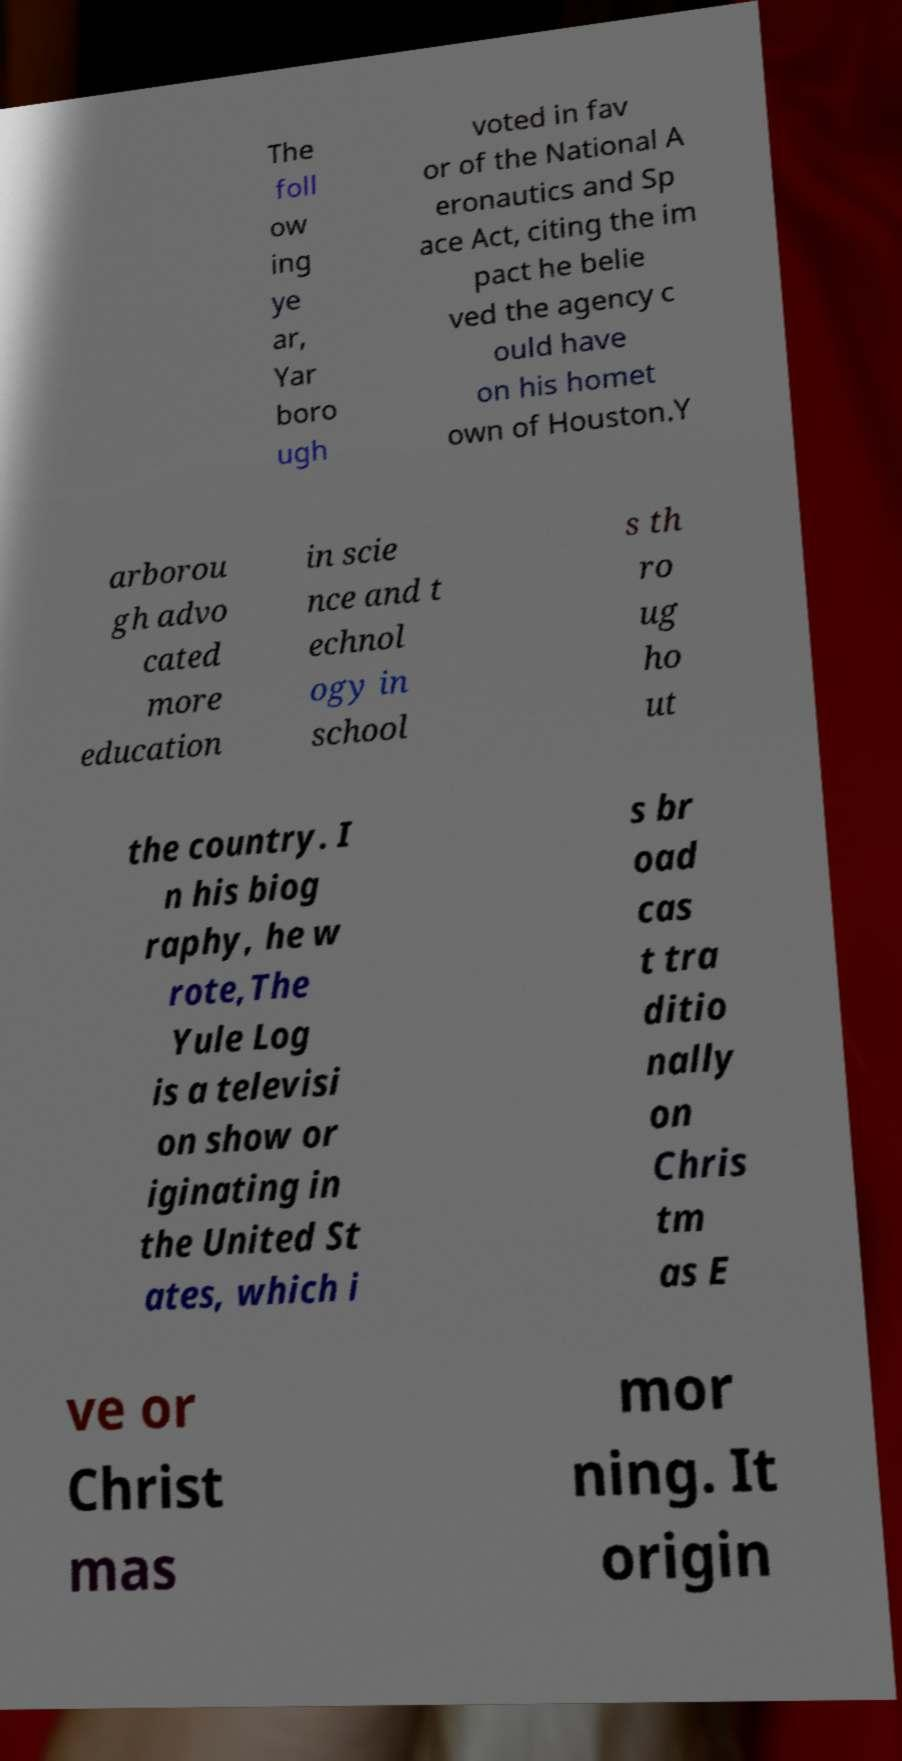Can you read and provide the text displayed in the image?This photo seems to have some interesting text. Can you extract and type it out for me? The foll ow ing ye ar, Yar boro ugh voted in fav or of the National A eronautics and Sp ace Act, citing the im pact he belie ved the agency c ould have on his homet own of Houston.Y arborou gh advo cated more education in scie nce and t echnol ogy in school s th ro ug ho ut the country. I n his biog raphy, he w rote,The Yule Log is a televisi on show or iginating in the United St ates, which i s br oad cas t tra ditio nally on Chris tm as E ve or Christ mas mor ning. It origin 